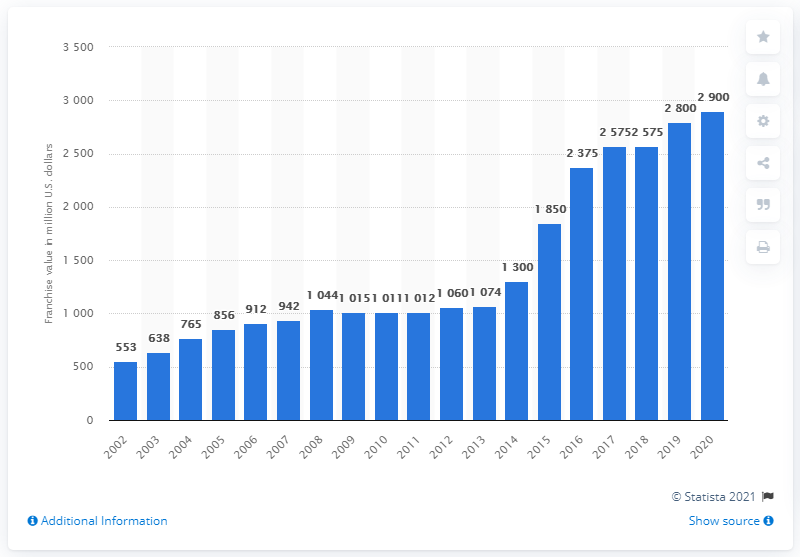Outline some significant characteristics in this image. In 2020, the Miami Dolphins were valued at approximately $2900 in dollars. 